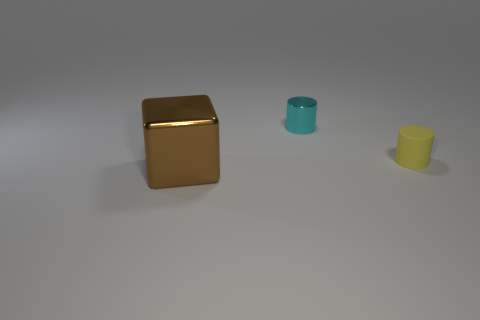Subtract all yellow cylinders. How many cylinders are left? 1 Add 1 tiny rubber objects. How many objects exist? 4 Subtract all cylinders. How many objects are left? 1 Subtract all gray cylinders. Subtract all gray blocks. How many cylinders are left? 2 Subtract all yellow spheres. How many yellow cylinders are left? 1 Subtract all big gray metallic spheres. Subtract all tiny matte objects. How many objects are left? 2 Add 1 small yellow things. How many small yellow things are left? 2 Add 1 small brown matte spheres. How many small brown matte spheres exist? 1 Subtract 0 blue cylinders. How many objects are left? 3 